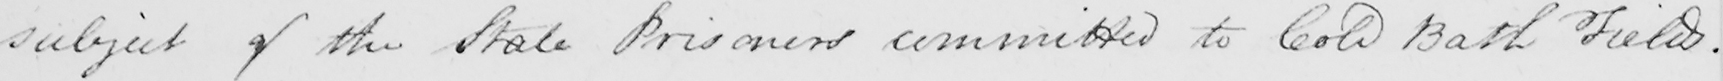What text is written in this handwritten line? subject of the State Prisoners committed to Cold Bath Fields . 